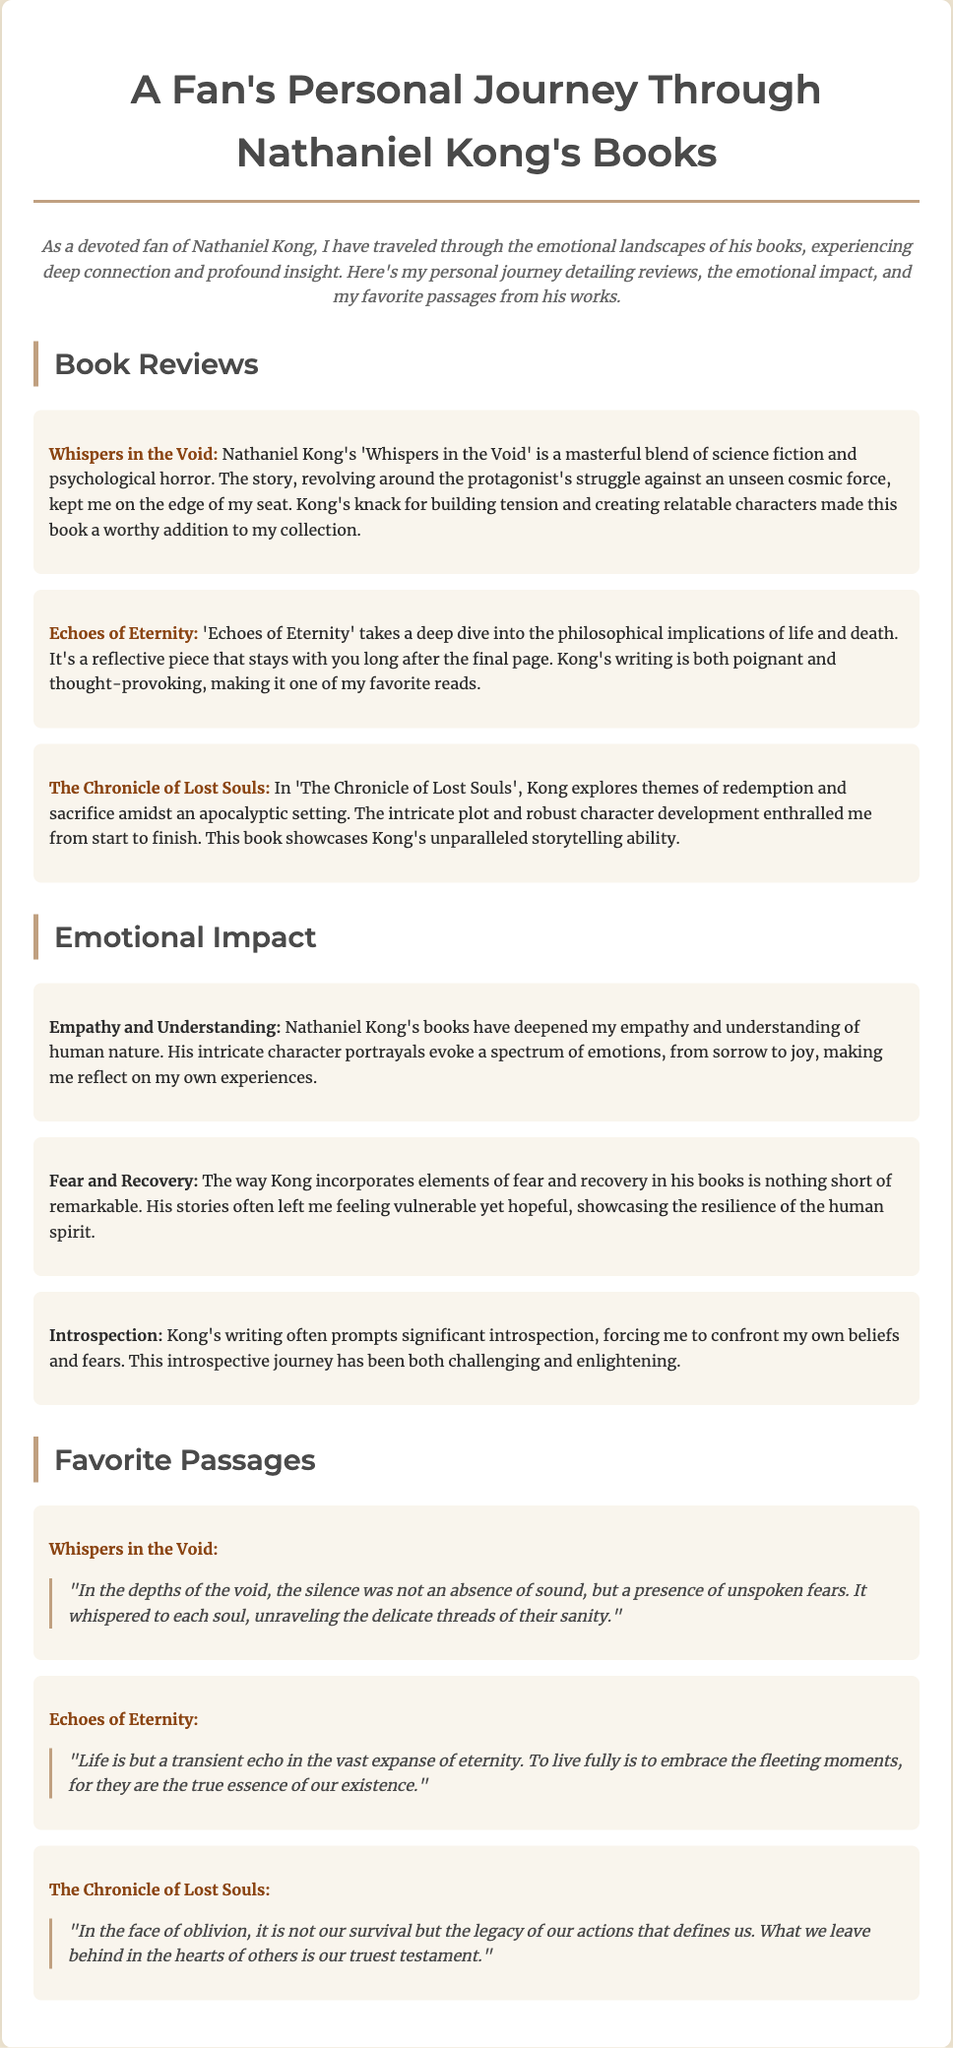What is the title of the first book reviewed? The title of the first book reviewed is found in the book reviews section and is 'Whispers in the Void'.
Answer: 'Whispers in the Void' What are the themes explored in 'The Chronicle of Lost Souls'? The themes in 'The Chronicle of Lost Souls' include redemption and sacrifice, as described in the review section.
Answer: Redemption and sacrifice How does the author evoke emotions through character portrayals? The document mentions that Nathaniel Kong's character portrayals evoke a spectrum of emotions, contributing to the emotional impact of his work.
Answer: Spectrum of emotions Which passage reflects the concept of legacy? The passage that reflects the concept of legacy is found in 'The Chronicle of Lost Souls', where it states the importance of our actions and what we leave behind.
Answer: "What we leave behind in the hearts of others is our truest testament." In which book does the quote about life's transient nature appear? The quote about life's transient nature can be found in the passage section under 'Echoes of Eternity'.
Answer: 'Echoes of Eternity' What is the emotional impact attributed to Nathaniel Kong's writing? The emotional impact attributed to his writing is deepening empathy and understanding of human nature, as stated in the document.
Answer: Empathy and understanding How many books are reviewed in the document? The document contains three book reviews, listed in the book reviews section.
Answer: Three Which theme discusses elements of fear? The theme that discusses elements of fear is detailed in the emotional impact section, and it's labeled 'Fear and Recovery'.
Answer: Fear and Recovery 